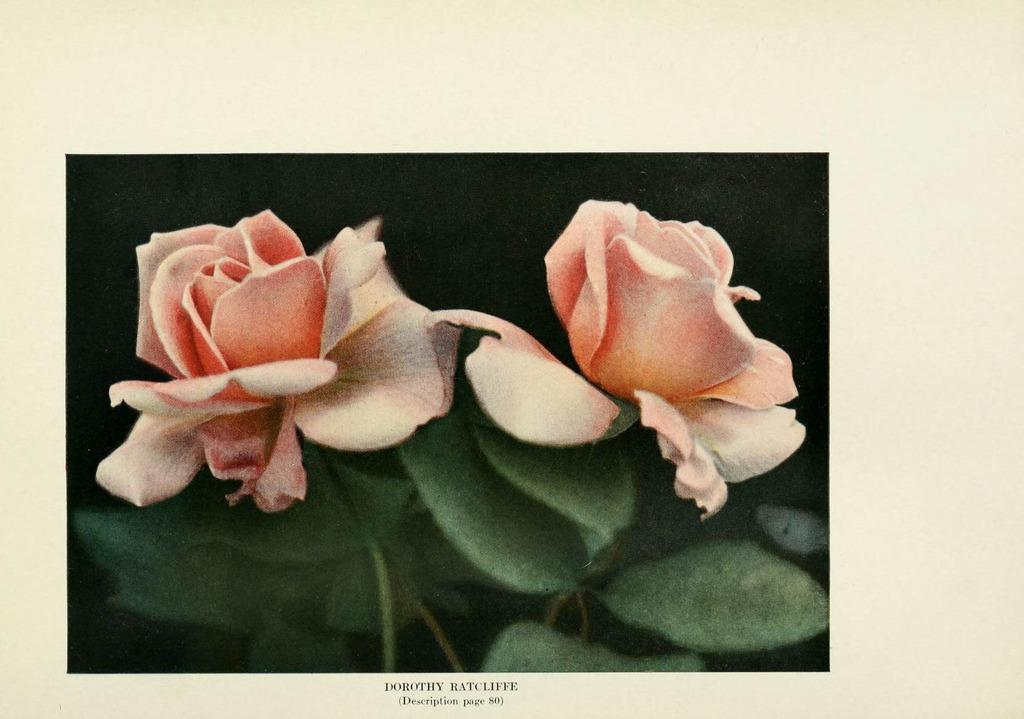What type of flowers are in the image? There are two pink roses in the image. What color are the leaves of the roses? The roses have green leaves. What type of paper is the image printed on? The image is on a magazine paper. How is the desire for roses distributed among the people in the image? There are no people present in the image, and therefore no distribution of desire for roses can be observed. 